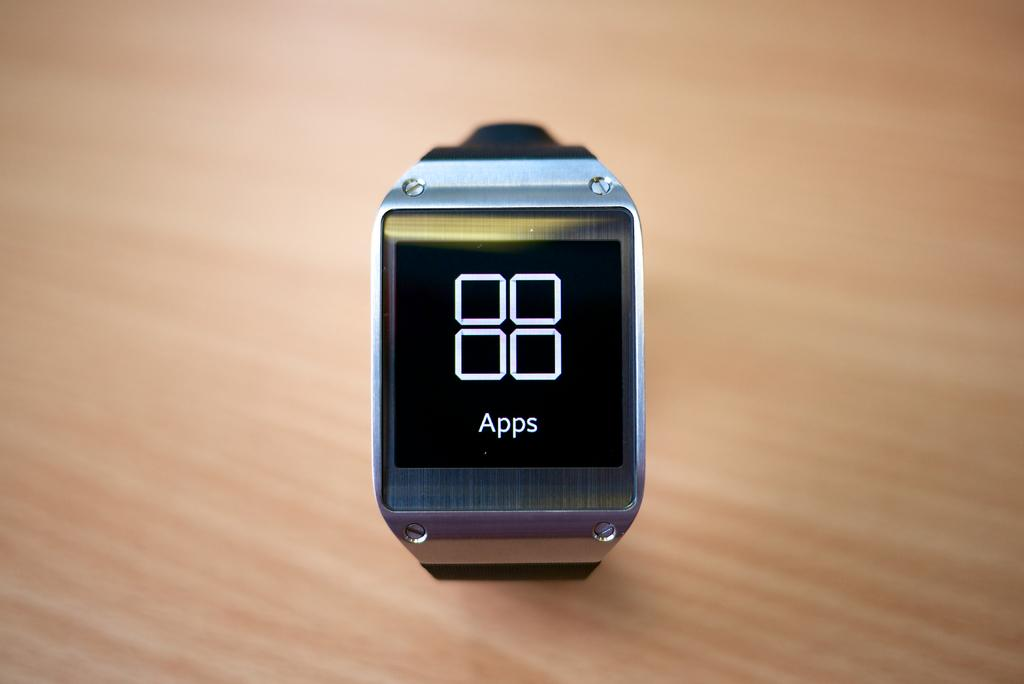<image>
Write a terse but informative summary of the picture. A smartwatch has the Apps screen showing on it. 